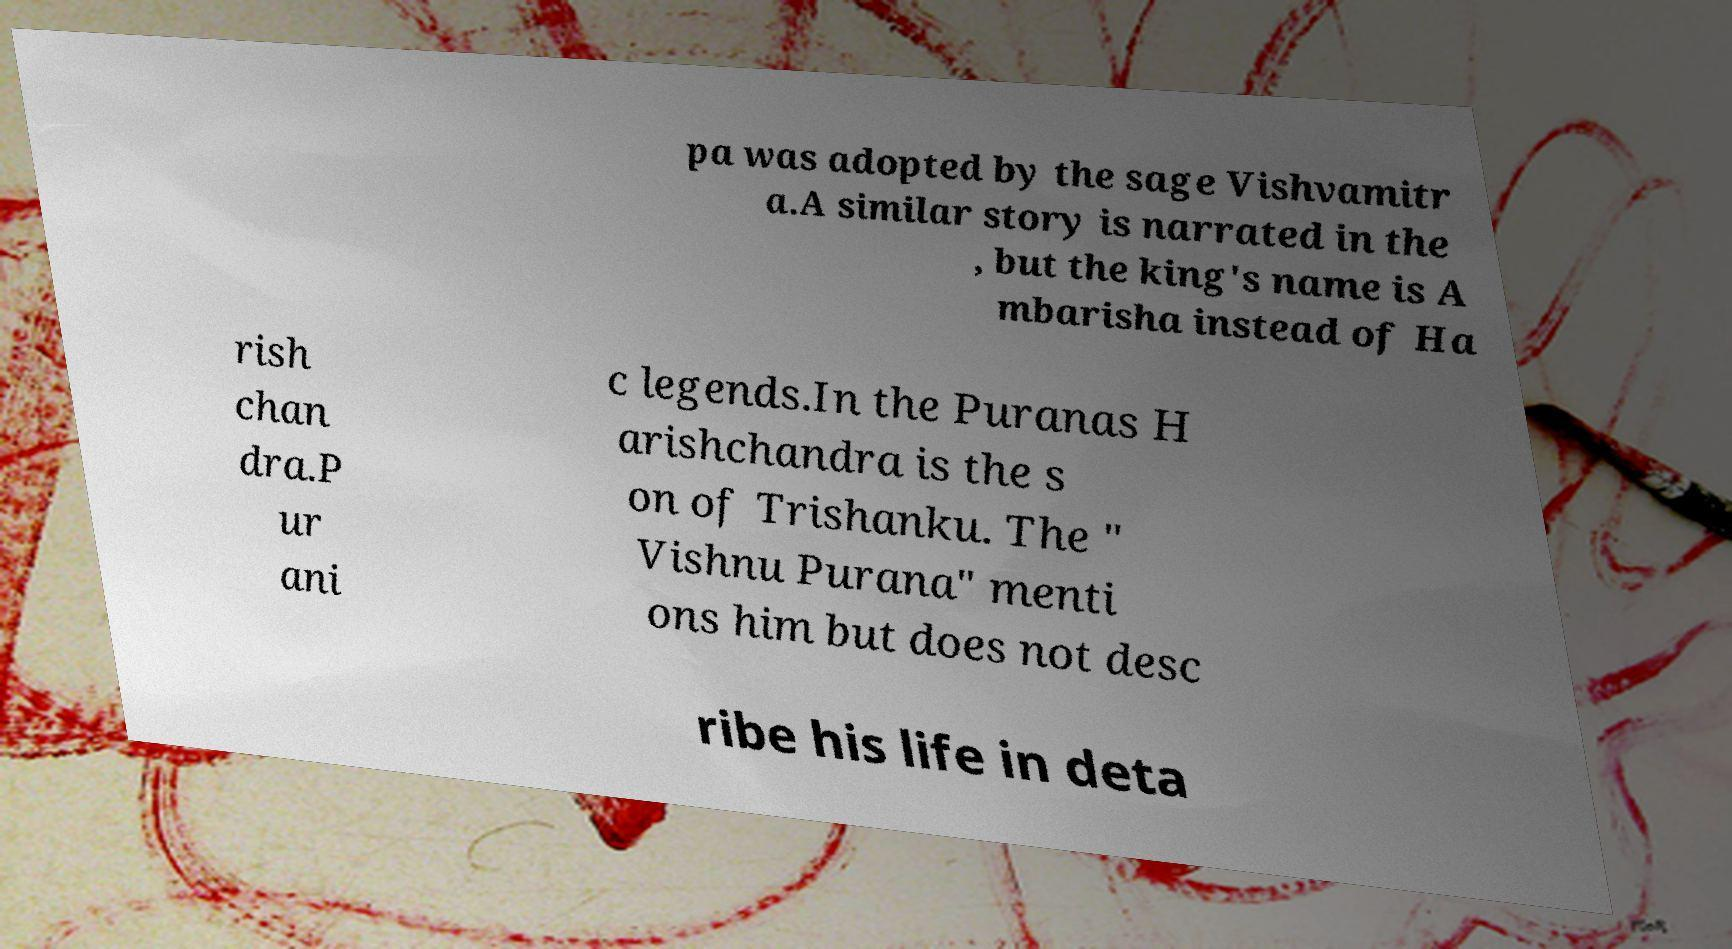For documentation purposes, I need the text within this image transcribed. Could you provide that? pa was adopted by the sage Vishvamitr a.A similar story is narrated in the , but the king's name is A mbarisha instead of Ha rish chan dra.P ur ani c legends.In the Puranas H arishchandra is the s on of Trishanku. The " Vishnu Purana" menti ons him but does not desc ribe his life in deta 